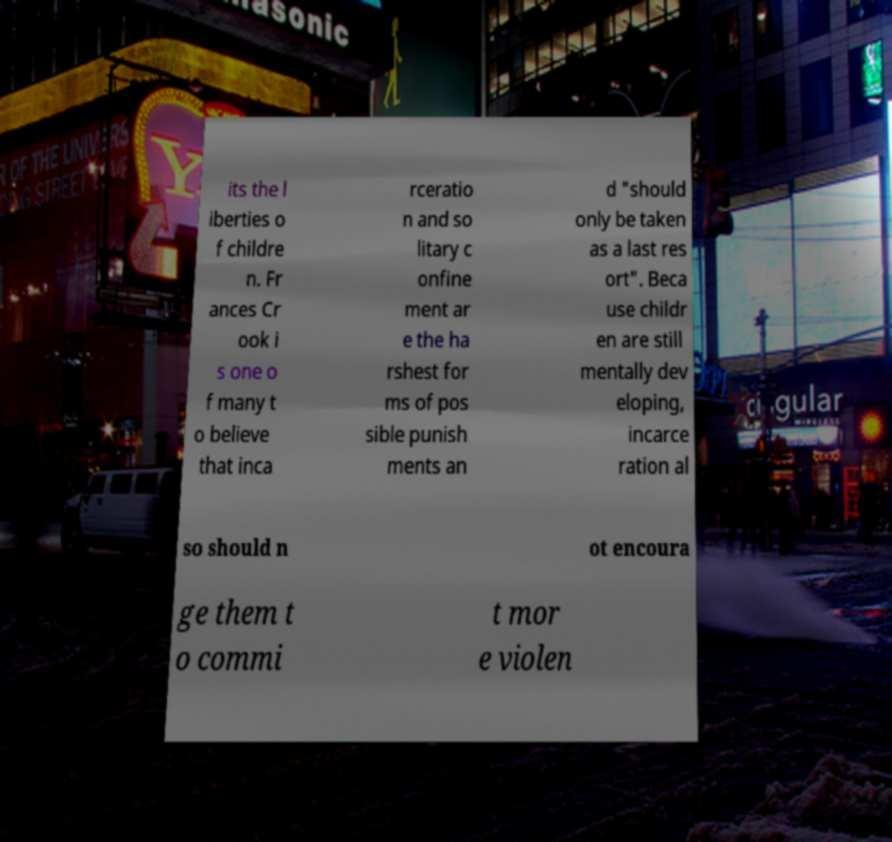Could you extract and type out the text from this image? its the l iberties o f childre n. Fr ances Cr ook i s one o f many t o believe that inca rceratio n and so litary c onfine ment ar e the ha rshest for ms of pos sible punish ments an d "should only be taken as a last res ort". Beca use childr en are still mentally dev eloping, incarce ration al so should n ot encoura ge them t o commi t mor e violen 